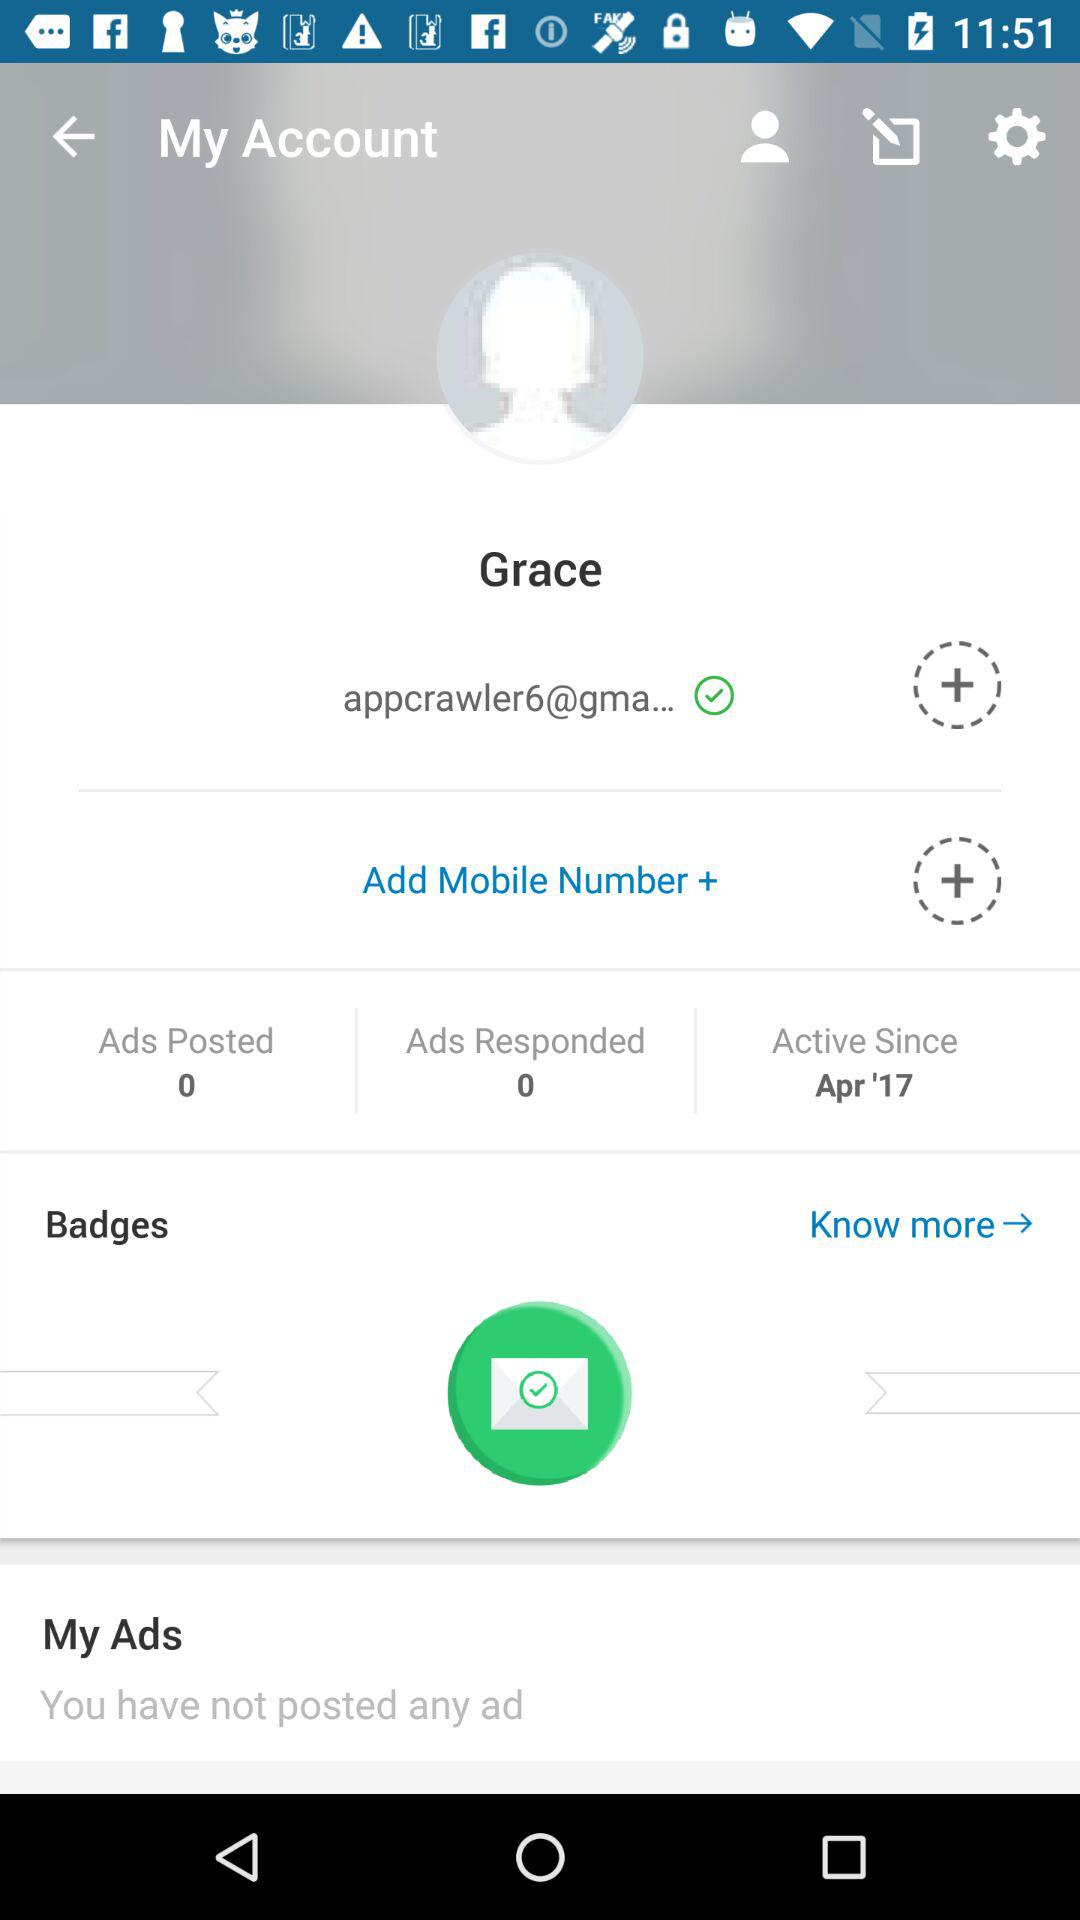How many ads has Grace posted?
Answer the question using a single word or phrase. 0 